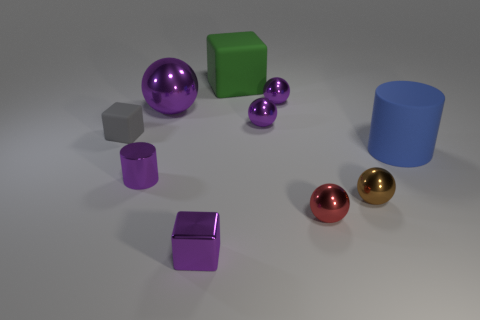How many yellow rubber cubes are the same size as the purple metal cylinder?
Give a very brief answer. 0. Are there any things that are behind the big thing in front of the tiny gray cube?
Ensure brevity in your answer.  Yes. What number of things are either shiny blocks or purple balls?
Give a very brief answer. 4. What is the color of the rubber cube that is to the right of the tiny block that is in front of the cylinder on the right side of the purple cube?
Keep it short and to the point. Green. Are there any other things that have the same color as the rubber cylinder?
Offer a terse response. No. Do the gray matte thing and the matte cylinder have the same size?
Offer a terse response. No. What number of things are either objects that are behind the brown shiny thing or small purple things that are in front of the blue matte cylinder?
Your response must be concise. 8. What material is the cylinder on the right side of the small cube in front of the large blue cylinder?
Offer a very short reply. Rubber. How many other things are made of the same material as the small purple cube?
Give a very brief answer. 6. Is the shape of the green matte thing the same as the tiny gray object?
Offer a very short reply. Yes. 